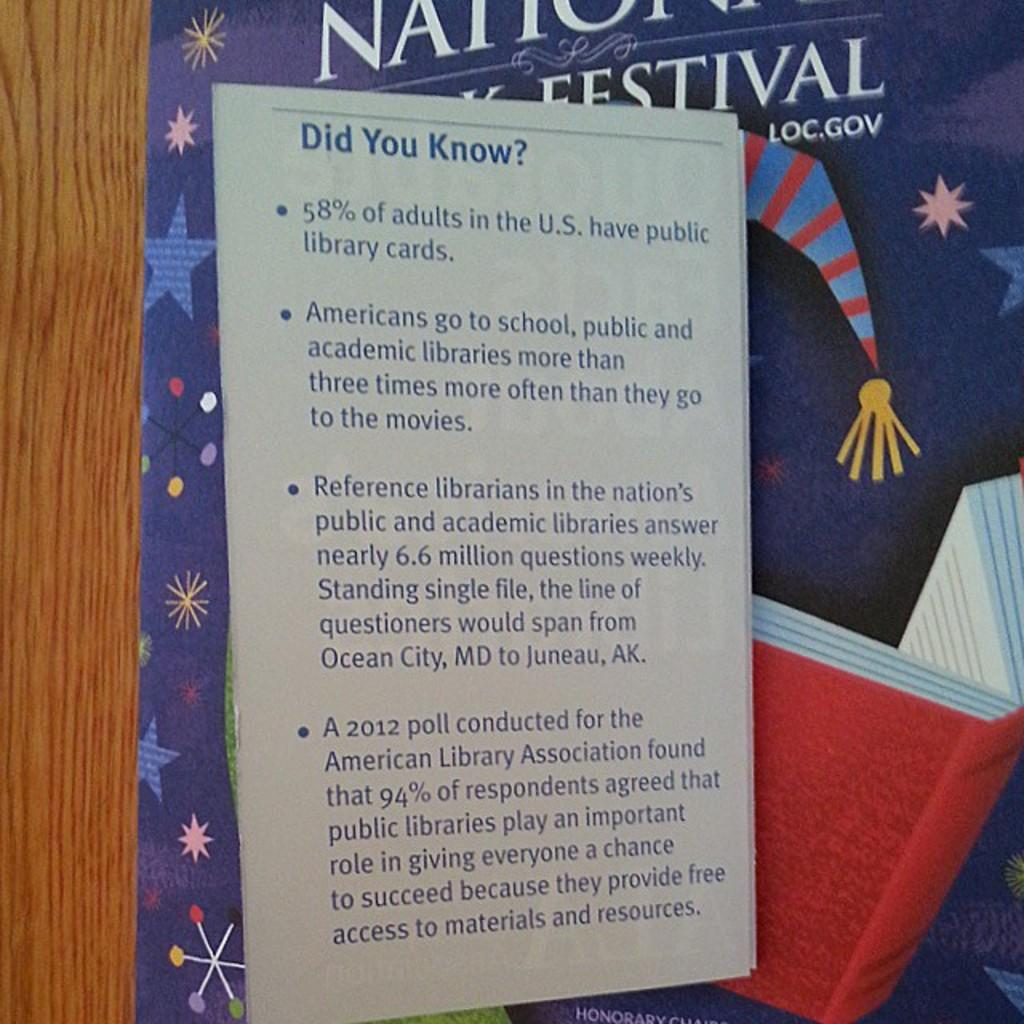<image>
Relay a brief, clear account of the picture shown. A poster with a Did You Know sign about Americans. 